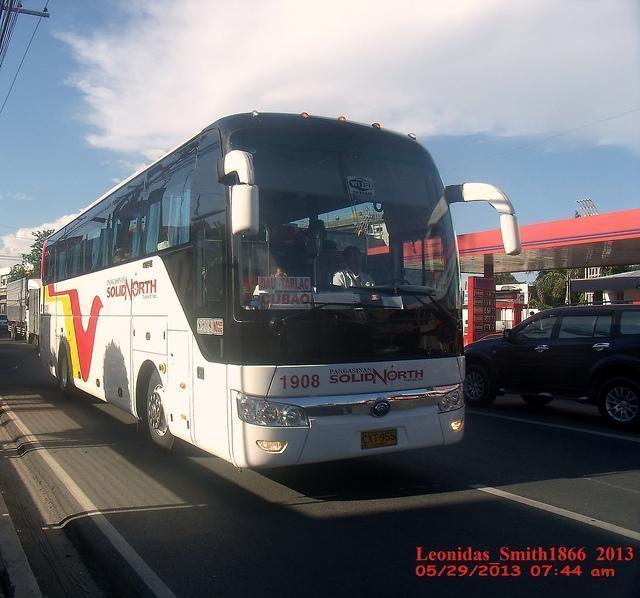What is the red building to the right of the bus used for?
Select the accurate response from the four choices given to answer the question.
Options: Convenience store, gas station, auto mechanic, grocery store. Gas station. 